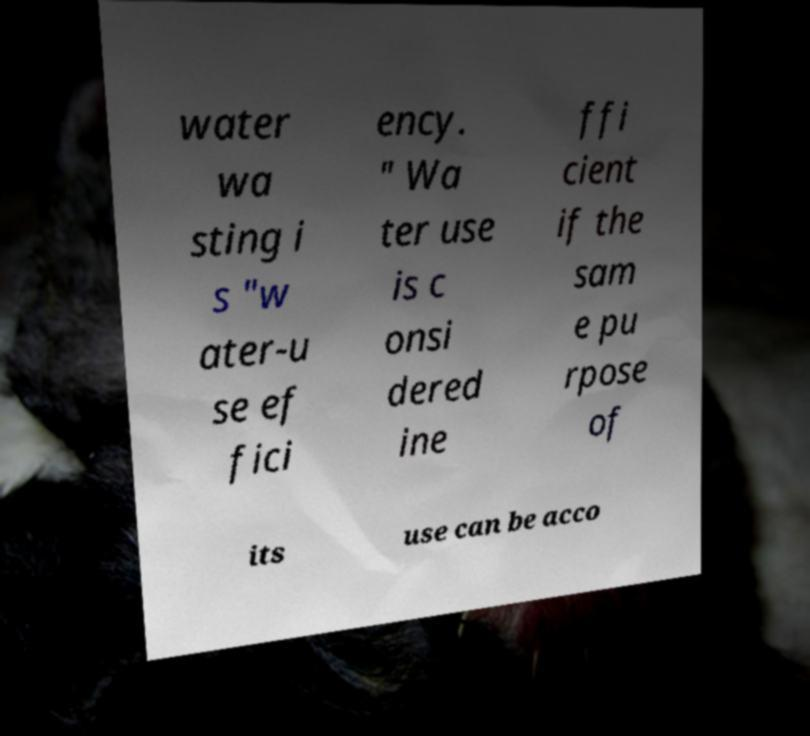I need the written content from this picture converted into text. Can you do that? water wa sting i s "w ater-u se ef fici ency. " Wa ter use is c onsi dered ine ffi cient if the sam e pu rpose of its use can be acco 